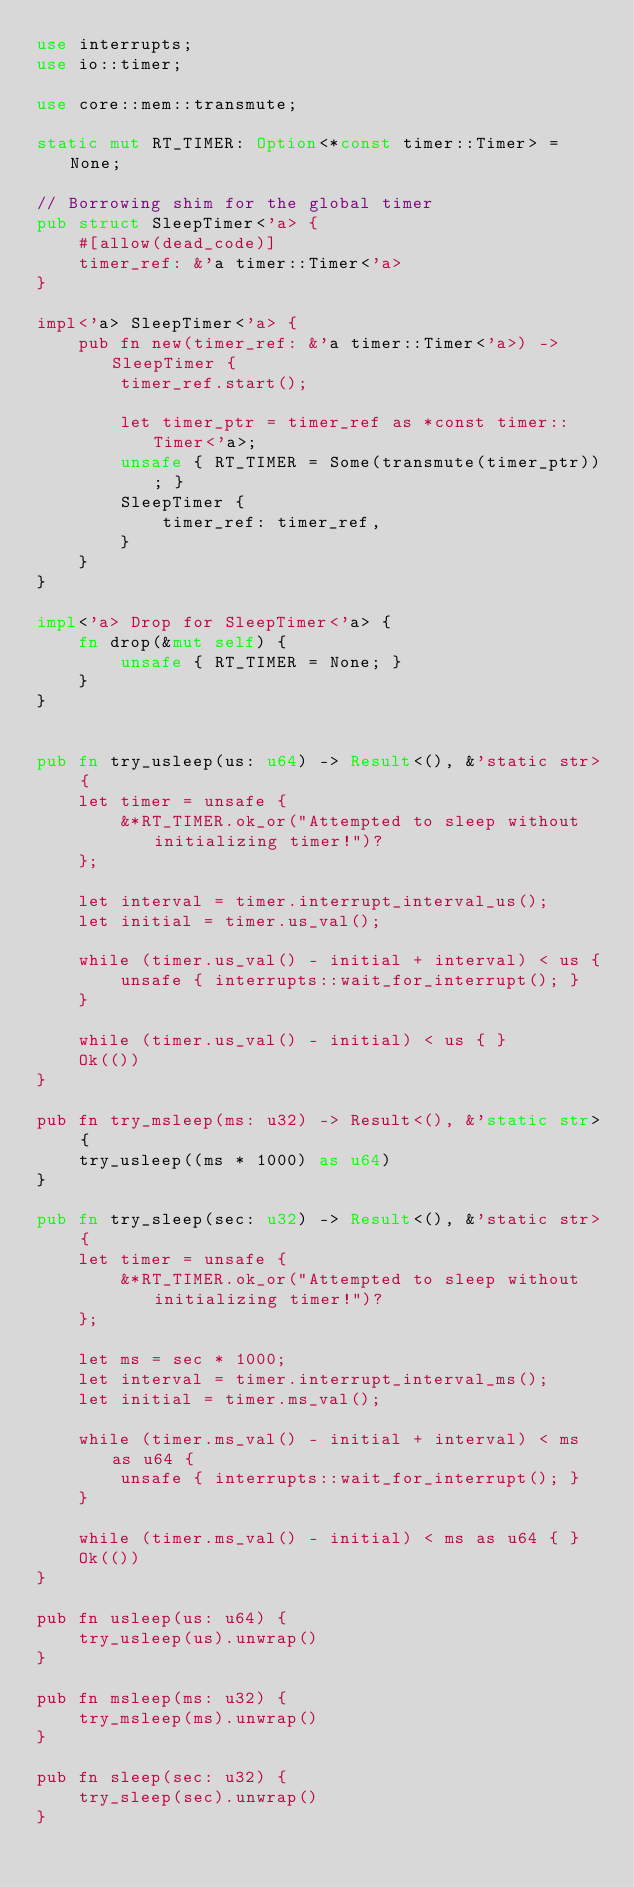Convert code to text. <code><loc_0><loc_0><loc_500><loc_500><_Rust_>use interrupts;
use io::timer;

use core::mem::transmute;

static mut RT_TIMER: Option<*const timer::Timer> = None;

// Borrowing shim for the global timer
pub struct SleepTimer<'a> {
    #[allow(dead_code)]
    timer_ref: &'a timer::Timer<'a>
}

impl<'a> SleepTimer<'a> {
    pub fn new(timer_ref: &'a timer::Timer<'a>) -> SleepTimer {
        timer_ref.start();

        let timer_ptr = timer_ref as *const timer::Timer<'a>;
        unsafe { RT_TIMER = Some(transmute(timer_ptr)); }
        SleepTimer {
            timer_ref: timer_ref,
        }
    }
}

impl<'a> Drop for SleepTimer<'a> {
    fn drop(&mut self) {
        unsafe { RT_TIMER = None; }
    }
}


pub fn try_usleep(us: u64) -> Result<(), &'static str> {
    let timer = unsafe {
        &*RT_TIMER.ok_or("Attempted to sleep without initializing timer!")?
    };

    let interval = timer.interrupt_interval_us();
    let initial = timer.us_val();

    while (timer.us_val() - initial + interval) < us {
        unsafe { interrupts::wait_for_interrupt(); }
    }

    while (timer.us_val() - initial) < us { }
    Ok(())
}

pub fn try_msleep(ms: u32) -> Result<(), &'static str> {
    try_usleep((ms * 1000) as u64)
}

pub fn try_sleep(sec: u32) -> Result<(), &'static str> {
    let timer = unsafe {
        &*RT_TIMER.ok_or("Attempted to sleep without initializing timer!")?
    };

    let ms = sec * 1000;
    let interval = timer.interrupt_interval_ms();
    let initial = timer.ms_val();

    while (timer.ms_val() - initial + interval) < ms as u64 {
        unsafe { interrupts::wait_for_interrupt(); }
    }

    while (timer.ms_val() - initial) < ms as u64 { }
    Ok(())
}

pub fn usleep(us: u64) {
    try_usleep(us).unwrap()
}

pub fn msleep(ms: u32) {
    try_msleep(ms).unwrap()
}

pub fn sleep(sec: u32) {
    try_sleep(sec).unwrap()
}
</code> 